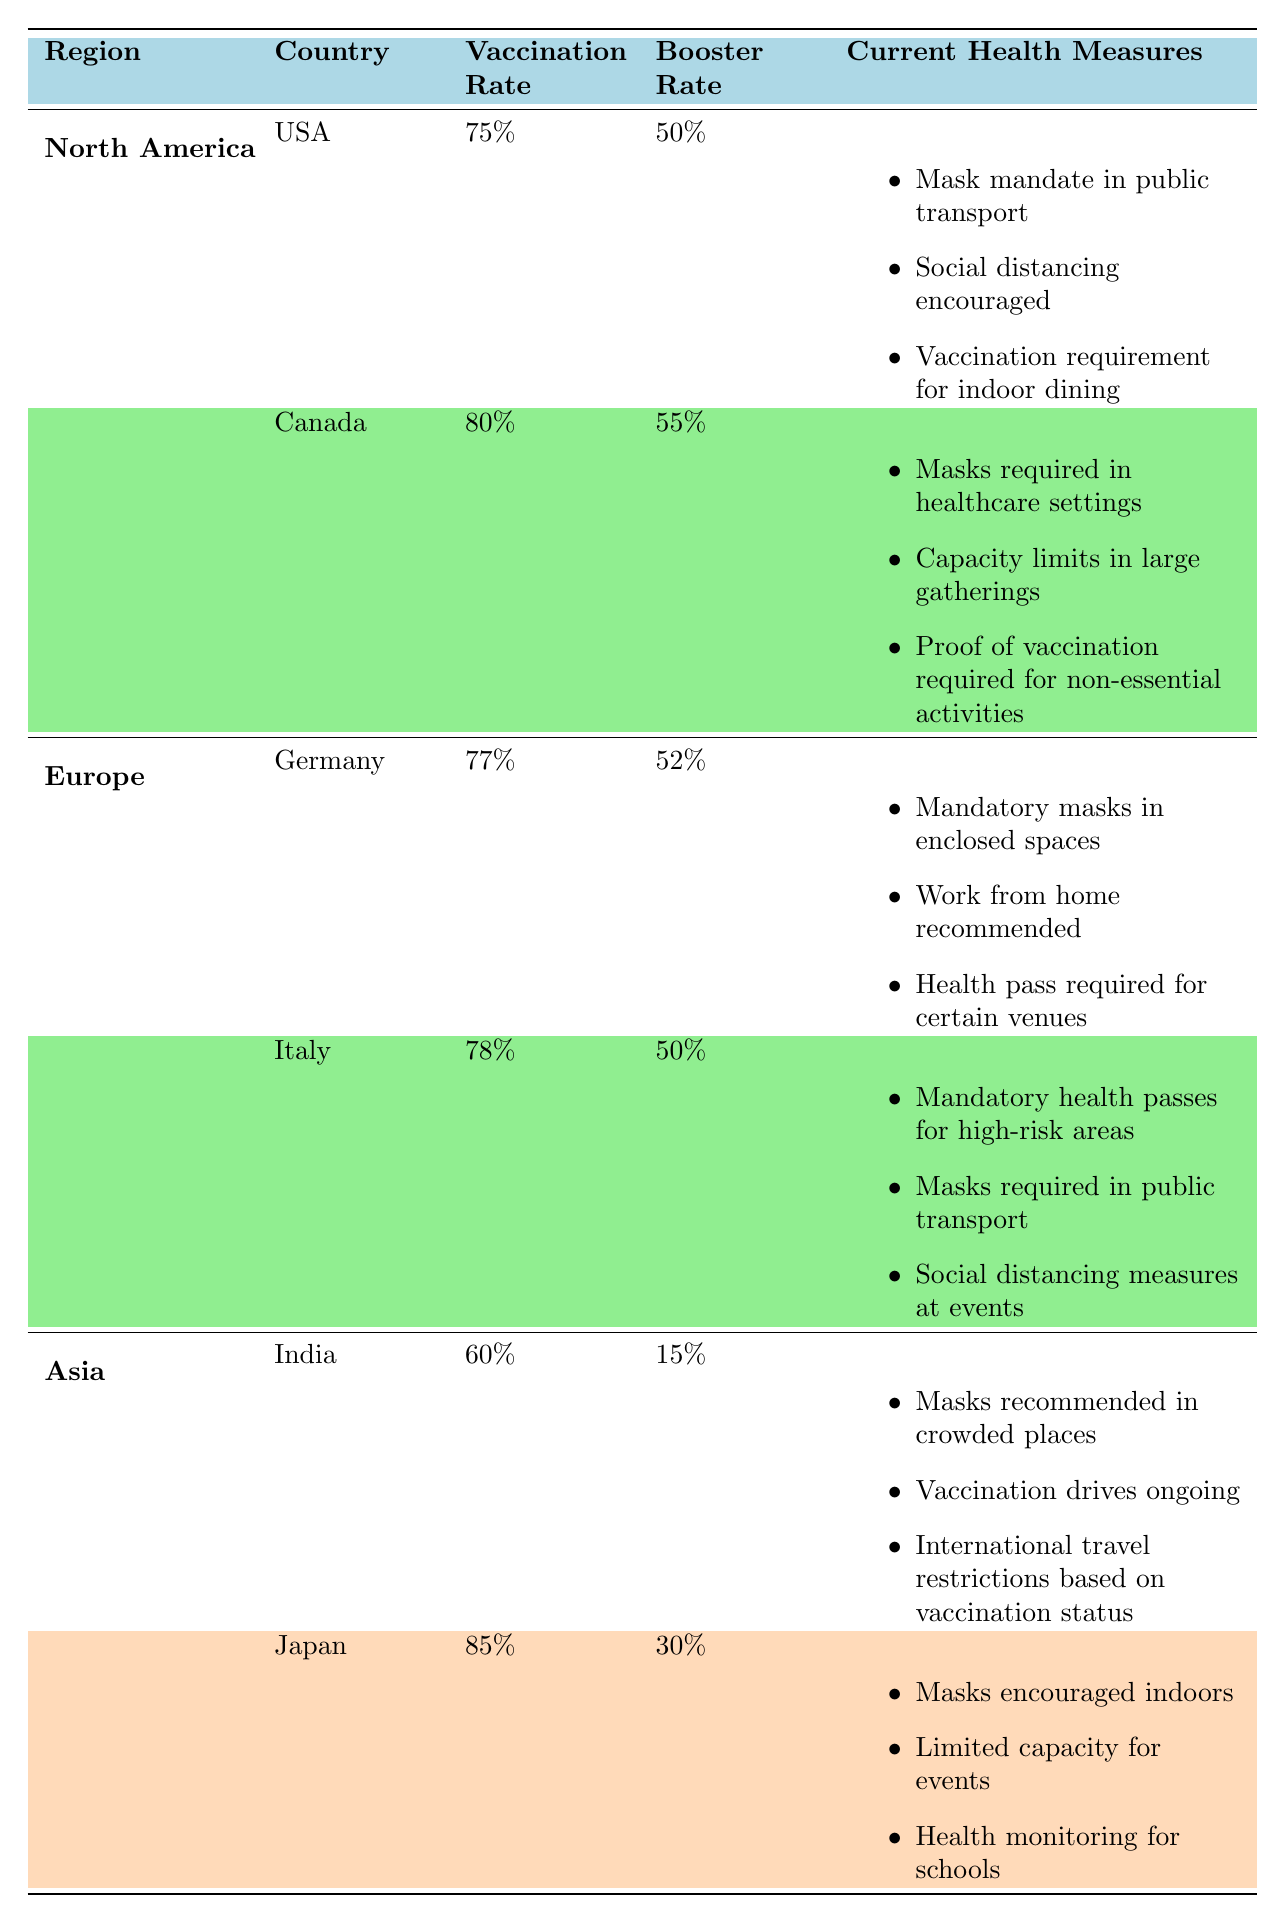What is the vaccination rate in Japan? Japan has a vaccination rate of 85%, which can be found in the table under the Asia section.
Answer: 85% Which country in North America has the highest booster rate? According to the table, Canada has a booster rate of 55%, while the USA has a booster rate of 50%. Hence, Canada has the highest booster rate in North America.
Answer: Canada Is the vaccination requirement for indoor dining in the USA? Yes, the table indicates that there is a vaccination requirement for indoor dining in the USA under the current health measures.
Answer: Yes What is the average vaccination rate for countries in Europe? The vaccination rates for Germany and Italy are 77% and 78%, respectively. The average is calculated as (77 + 78) / 2 = 77.5%.
Answer: 77.5% Does India have a higher booster rate than Japan? No, India has a booster rate of 15%, and Japan has a booster rate of 30%. Therefore, India does not have a higher booster rate than Japan.
Answer: No Which region has the lowest vaccination rate? Among all the countries listed, India has the lowest vaccination rate at 60%. This data is gathered from the Asia section of the table, which includes the vaccination rates for other countries as well.
Answer: Asia What is the difference in vaccination rates between Canada and the USA? Canada has a vaccination rate of 80%, while the USA has a vaccination rate of 75%. The difference is calculated as 80 - 75 = 5%.
Answer: 5% How many countries in North America have a vaccination rate over 75%? The table shows two countries listed under North America: the USA with a 75% rate and Canada with an 80% rate. Therefore, only Canada has a vaccination rate over 75%.
Answer: 1 Compare the health measures between Germany and Italy. In Germany, the health measures include mandatory masks in enclosed spaces, work from home recommended, and a health pass required for certain venues. Italy’s health measures include mandatory health passes for high-risk areas, masks required in public transport, and social distancing measures at events. This comparison shows that while both countries have masks required, their other measures differ slightly.
Answer: They have different measures 